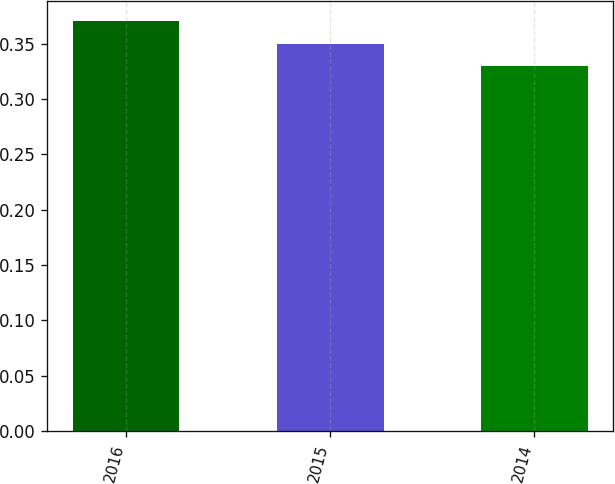Convert chart to OTSL. <chart><loc_0><loc_0><loc_500><loc_500><bar_chart><fcel>2016<fcel>2015<fcel>2014<nl><fcel>0.37<fcel>0.35<fcel>0.33<nl></chart> 